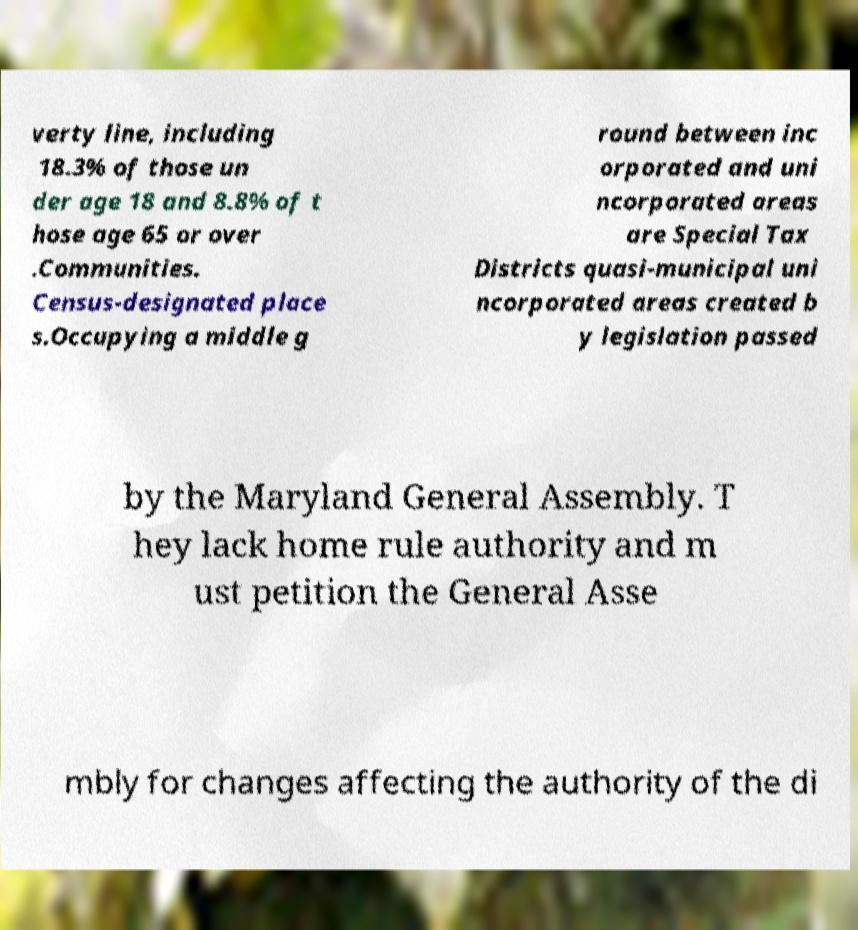Could you assist in decoding the text presented in this image and type it out clearly? verty line, including 18.3% of those un der age 18 and 8.8% of t hose age 65 or over .Communities. Census-designated place s.Occupying a middle g round between inc orporated and uni ncorporated areas are Special Tax Districts quasi-municipal uni ncorporated areas created b y legislation passed by the Maryland General Assembly. T hey lack home rule authority and m ust petition the General Asse mbly for changes affecting the authority of the di 